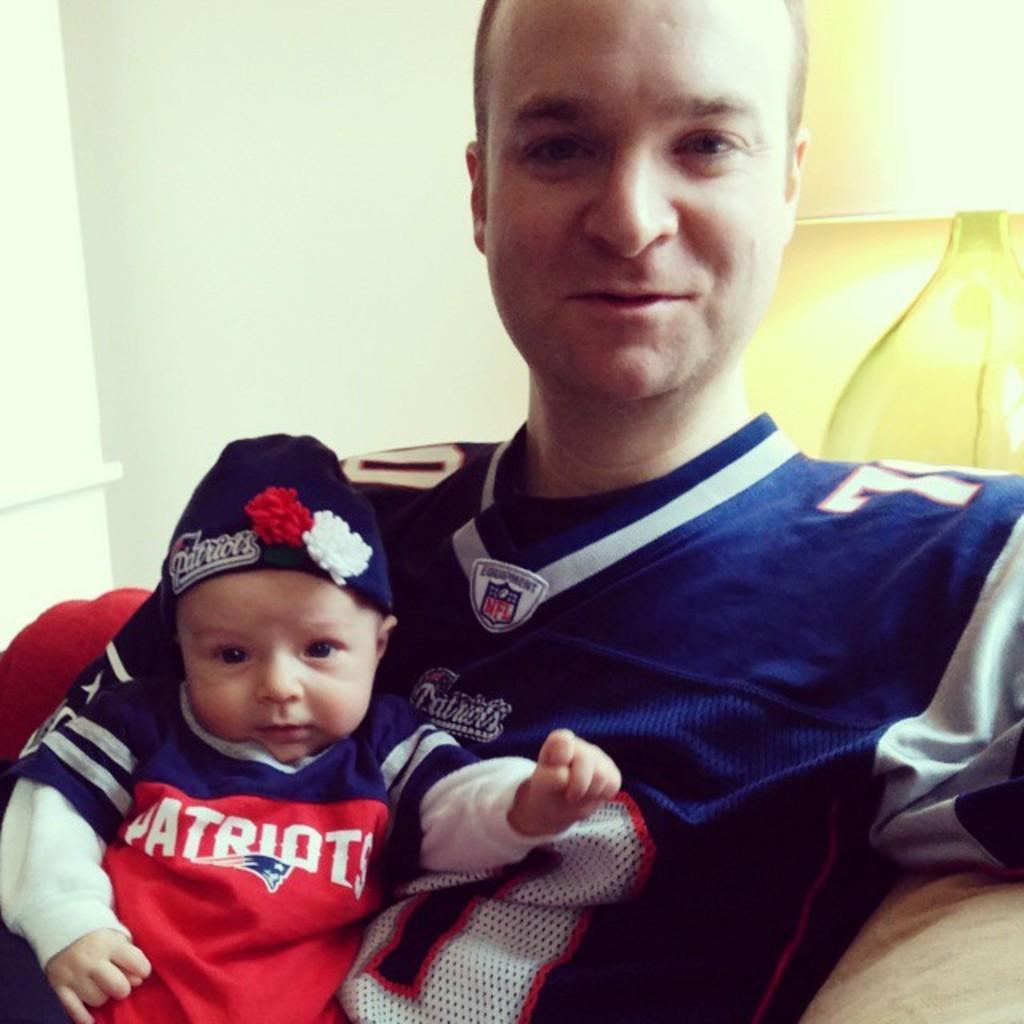<image>
Write a terse but informative summary of the picture. a little baby has the word Patriots on their shirt 